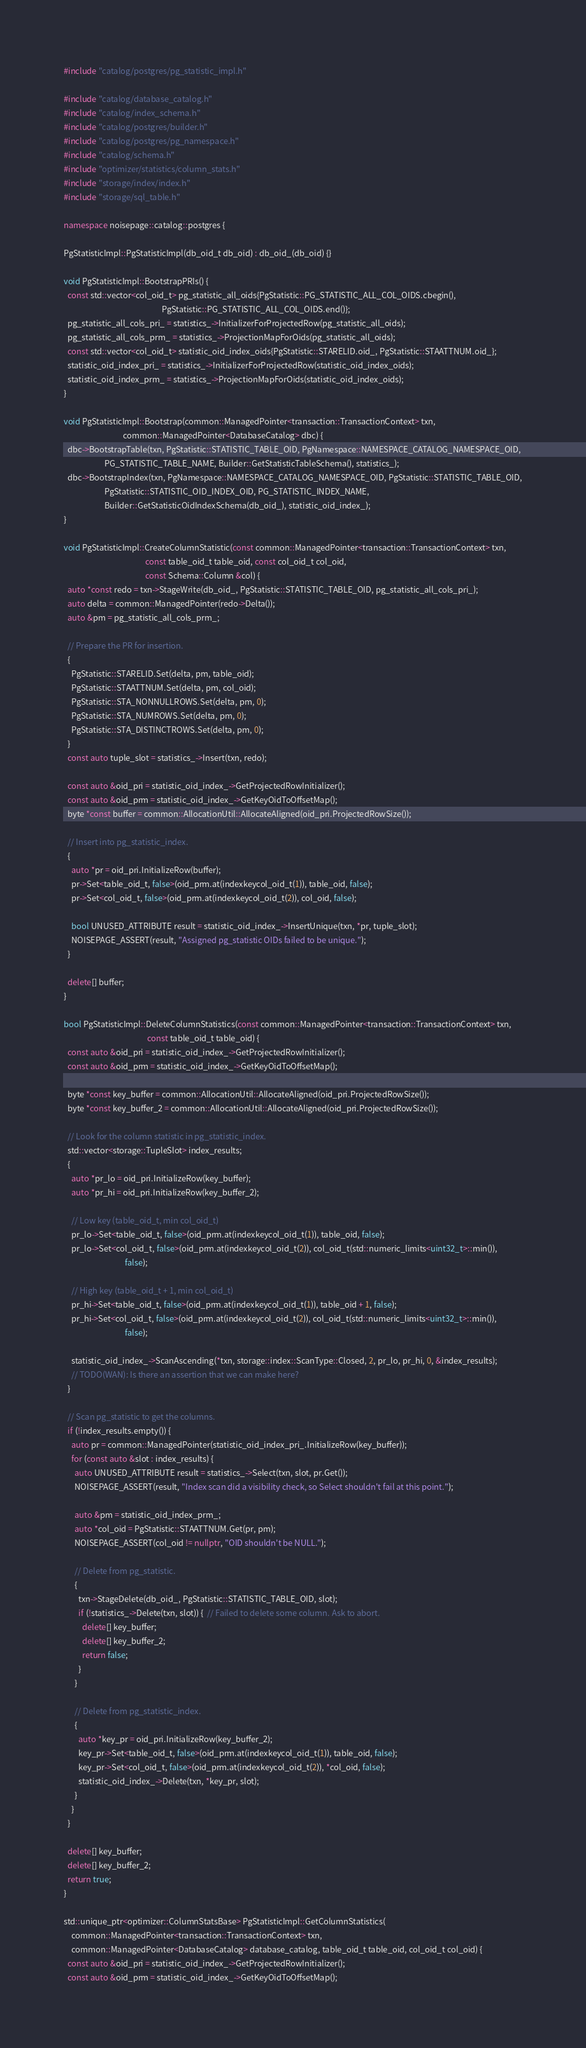Convert code to text. <code><loc_0><loc_0><loc_500><loc_500><_C++_>#include "catalog/postgres/pg_statistic_impl.h"

#include "catalog/database_catalog.h"
#include "catalog/index_schema.h"
#include "catalog/postgres/builder.h"
#include "catalog/postgres/pg_namespace.h"
#include "catalog/schema.h"
#include "optimizer/statistics/column_stats.h"
#include "storage/index/index.h"
#include "storage/sql_table.h"

namespace noisepage::catalog::postgres {

PgStatisticImpl::PgStatisticImpl(db_oid_t db_oid) : db_oid_(db_oid) {}

void PgStatisticImpl::BootstrapPRIs() {
  const std::vector<col_oid_t> pg_statistic_all_oids{PgStatistic::PG_STATISTIC_ALL_COL_OIDS.cbegin(),
                                                     PgStatistic::PG_STATISTIC_ALL_COL_OIDS.end()};
  pg_statistic_all_cols_pri_ = statistics_->InitializerForProjectedRow(pg_statistic_all_oids);
  pg_statistic_all_cols_prm_ = statistics_->ProjectionMapForOids(pg_statistic_all_oids);
  const std::vector<col_oid_t> statistic_oid_index_oids{PgStatistic::STARELID.oid_, PgStatistic::STAATTNUM.oid_};
  statistic_oid_index_pri_ = statistics_->InitializerForProjectedRow(statistic_oid_index_oids);
  statistic_oid_index_prm_ = statistics_->ProjectionMapForOids(statistic_oid_index_oids);
}

void PgStatisticImpl::Bootstrap(common::ManagedPointer<transaction::TransactionContext> txn,
                                common::ManagedPointer<DatabaseCatalog> dbc) {
  dbc->BootstrapTable(txn, PgStatistic::STATISTIC_TABLE_OID, PgNamespace::NAMESPACE_CATALOG_NAMESPACE_OID,
                      PG_STATISTIC_TABLE_NAME, Builder::GetStatisticTableSchema(), statistics_);
  dbc->BootstrapIndex(txn, PgNamespace::NAMESPACE_CATALOG_NAMESPACE_OID, PgStatistic::STATISTIC_TABLE_OID,
                      PgStatistic::STATISTIC_OID_INDEX_OID, PG_STATISTIC_INDEX_NAME,
                      Builder::GetStatisticOidIndexSchema(db_oid_), statistic_oid_index_);
}

void PgStatisticImpl::CreateColumnStatistic(const common::ManagedPointer<transaction::TransactionContext> txn,
                                            const table_oid_t table_oid, const col_oid_t col_oid,
                                            const Schema::Column &col) {
  auto *const redo = txn->StageWrite(db_oid_, PgStatistic::STATISTIC_TABLE_OID, pg_statistic_all_cols_pri_);
  auto delta = common::ManagedPointer(redo->Delta());
  auto &pm = pg_statistic_all_cols_prm_;

  // Prepare the PR for insertion.
  {
    PgStatistic::STARELID.Set(delta, pm, table_oid);
    PgStatistic::STAATTNUM.Set(delta, pm, col_oid);
    PgStatistic::STA_NONNULLROWS.Set(delta, pm, 0);
    PgStatistic::STA_NUMROWS.Set(delta, pm, 0);
    PgStatistic::STA_DISTINCTROWS.Set(delta, pm, 0);
  }
  const auto tuple_slot = statistics_->Insert(txn, redo);

  const auto &oid_pri = statistic_oid_index_->GetProjectedRowInitializer();
  const auto &oid_prm = statistic_oid_index_->GetKeyOidToOffsetMap();
  byte *const buffer = common::AllocationUtil::AllocateAligned(oid_pri.ProjectedRowSize());

  // Insert into pg_statistic_index.
  {
    auto *pr = oid_pri.InitializeRow(buffer);
    pr->Set<table_oid_t, false>(oid_prm.at(indexkeycol_oid_t(1)), table_oid, false);
    pr->Set<col_oid_t, false>(oid_prm.at(indexkeycol_oid_t(2)), col_oid, false);

    bool UNUSED_ATTRIBUTE result = statistic_oid_index_->InsertUnique(txn, *pr, tuple_slot);
    NOISEPAGE_ASSERT(result, "Assigned pg_statistic OIDs failed to be unique.");
  }

  delete[] buffer;
}

bool PgStatisticImpl::DeleteColumnStatistics(const common::ManagedPointer<transaction::TransactionContext> txn,
                                             const table_oid_t table_oid) {
  const auto &oid_pri = statistic_oid_index_->GetProjectedRowInitializer();
  const auto &oid_prm = statistic_oid_index_->GetKeyOidToOffsetMap();

  byte *const key_buffer = common::AllocationUtil::AllocateAligned(oid_pri.ProjectedRowSize());
  byte *const key_buffer_2 = common::AllocationUtil::AllocateAligned(oid_pri.ProjectedRowSize());

  // Look for the column statistic in pg_statistic_index.
  std::vector<storage::TupleSlot> index_results;
  {
    auto *pr_lo = oid_pri.InitializeRow(key_buffer);
    auto *pr_hi = oid_pri.InitializeRow(key_buffer_2);

    // Low key (table_oid_t, min col_oid_t)
    pr_lo->Set<table_oid_t, false>(oid_prm.at(indexkeycol_oid_t(1)), table_oid, false);
    pr_lo->Set<col_oid_t, false>(oid_prm.at(indexkeycol_oid_t(2)), col_oid_t(std::numeric_limits<uint32_t>::min()),
                                 false);

    // High key (table_oid_t + 1, min col_oid_t)
    pr_hi->Set<table_oid_t, false>(oid_prm.at(indexkeycol_oid_t(1)), table_oid + 1, false);
    pr_hi->Set<col_oid_t, false>(oid_prm.at(indexkeycol_oid_t(2)), col_oid_t(std::numeric_limits<uint32_t>::min()),
                                 false);

    statistic_oid_index_->ScanAscending(*txn, storage::index::ScanType::Closed, 2, pr_lo, pr_hi, 0, &index_results);
    // TODO(WAN): Is there an assertion that we can make here?
  }

  // Scan pg_statistic to get the columns.
  if (!index_results.empty()) {
    auto pr = common::ManagedPointer(statistic_oid_index_pri_.InitializeRow(key_buffer));
    for (const auto &slot : index_results) {
      auto UNUSED_ATTRIBUTE result = statistics_->Select(txn, slot, pr.Get());
      NOISEPAGE_ASSERT(result, "Index scan did a visibility check, so Select shouldn't fail at this point.");

      auto &pm = statistic_oid_index_prm_;
      auto *col_oid = PgStatistic::STAATTNUM.Get(pr, pm);
      NOISEPAGE_ASSERT(col_oid != nullptr, "OID shouldn't be NULL.");

      // Delete from pg_statistic.
      {
        txn->StageDelete(db_oid_, PgStatistic::STATISTIC_TABLE_OID, slot);
        if (!statistics_->Delete(txn, slot)) {  // Failed to delete some column. Ask to abort.
          delete[] key_buffer;
          delete[] key_buffer_2;
          return false;
        }
      }

      // Delete from pg_statistic_index.
      {
        auto *key_pr = oid_pri.InitializeRow(key_buffer_2);
        key_pr->Set<table_oid_t, false>(oid_prm.at(indexkeycol_oid_t(1)), table_oid, false);
        key_pr->Set<col_oid_t, false>(oid_prm.at(indexkeycol_oid_t(2)), *col_oid, false);
        statistic_oid_index_->Delete(txn, *key_pr, slot);
      }
    }
  }

  delete[] key_buffer;
  delete[] key_buffer_2;
  return true;
}

std::unique_ptr<optimizer::ColumnStatsBase> PgStatisticImpl::GetColumnStatistics(
    common::ManagedPointer<transaction::TransactionContext> txn,
    common::ManagedPointer<DatabaseCatalog> database_catalog, table_oid_t table_oid, col_oid_t col_oid) {
  const auto &oid_pri = statistic_oid_index_->GetProjectedRowInitializer();
  const auto &oid_prm = statistic_oid_index_->GetKeyOidToOffsetMap();
</code> 